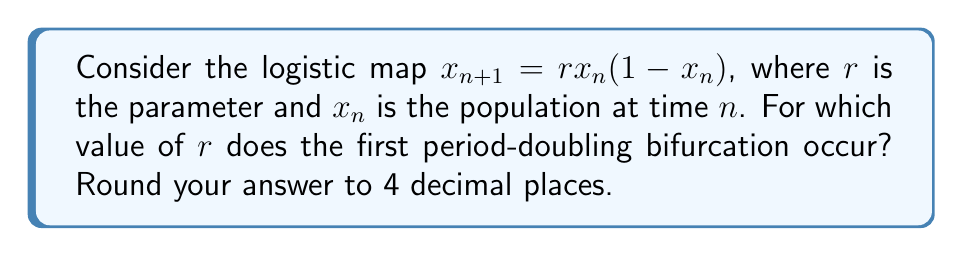Give your solution to this math problem. Let's approach this step-by-step:

1) The logistic map has a fixed point when $x_{n+1} = x_n$. Let's call this fixed point $x^*$.

2) We can find $x^*$ by solving:
   $x^* = rx^*(1-x^*)$

3) Solving this equation gives us two fixed points:
   $x^* = 0$ and $x^* = 1 - \frac{1}{r}$

4) The non-zero fixed point $x^* = 1 - \frac{1}{r}$ is stable when $|\frac{d}{dx}(rx(1-x))| < 1$ at $x = x^*$.

5) Calculating the derivative:
   $\frac{d}{dx}(rx(1-x)) = r(1-2x)$

6) Evaluating at $x^*$:
   $|r(1-2(1-\frac{1}{r}))| = |r(1-2+\frac{2}{r})| = |2-r| < 1$

7) This inequality is satisfied when $1 < r < 3$.

8) The first period-doubling bifurcation occurs when this fixed point becomes unstable, i.e., when $r = 3$.

Therefore, the first period-doubling bifurcation occurs when $r = 3.0000$.
Answer: 3.0000 